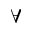<formula> <loc_0><loc_0><loc_500><loc_500>\forall</formula> 